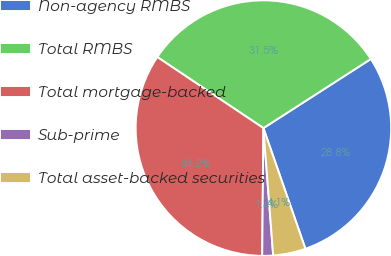Convert chart to OTSL. <chart><loc_0><loc_0><loc_500><loc_500><pie_chart><fcel>Non-agency RMBS<fcel>Total RMBS<fcel>Total mortgage-backed<fcel>Sub-prime<fcel>Total asset-backed securities<nl><fcel>28.77%<fcel>31.51%<fcel>34.24%<fcel>1.37%<fcel>4.11%<nl></chart> 